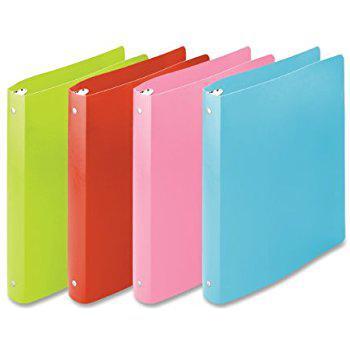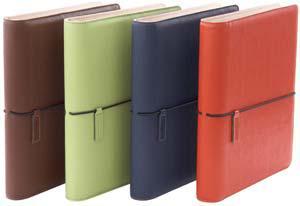The first image is the image on the left, the second image is the image on the right. Examine the images to the left and right. Is the description "An image shows a single upright binder, which is dark burgundy-brownish in color." accurate? Answer yes or no. No. The first image is the image on the left, the second image is the image on the right. Evaluate the accuracy of this statement regarding the images: "Two leather binders are shown, one closed and the other open flat, showing its interior layout.". Is it true? Answer yes or no. No. 